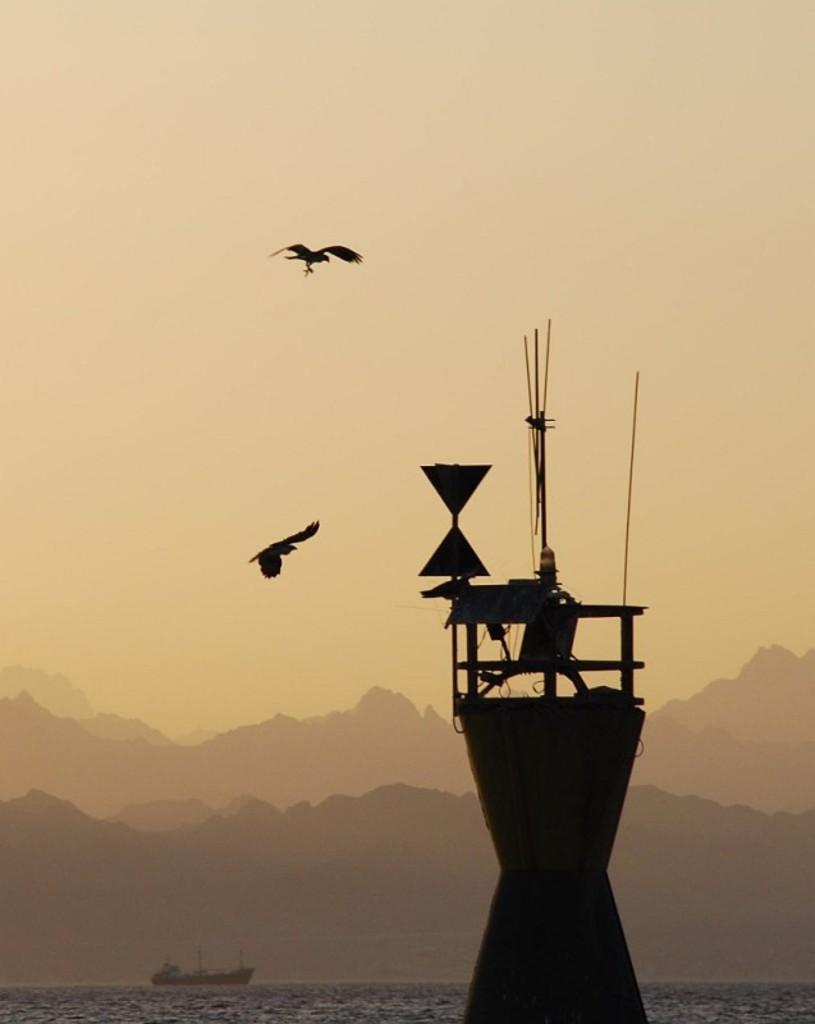Can you describe this image briefly? In this image, we can see a tower. There is a boat floating on the water. There are hills at the bottom of the image. There are birds in the sky. 